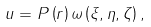<formula> <loc_0><loc_0><loc_500><loc_500>u = P \left ( r \right ) \omega \left ( { \xi , \eta , \zeta } \right ) ,</formula> 